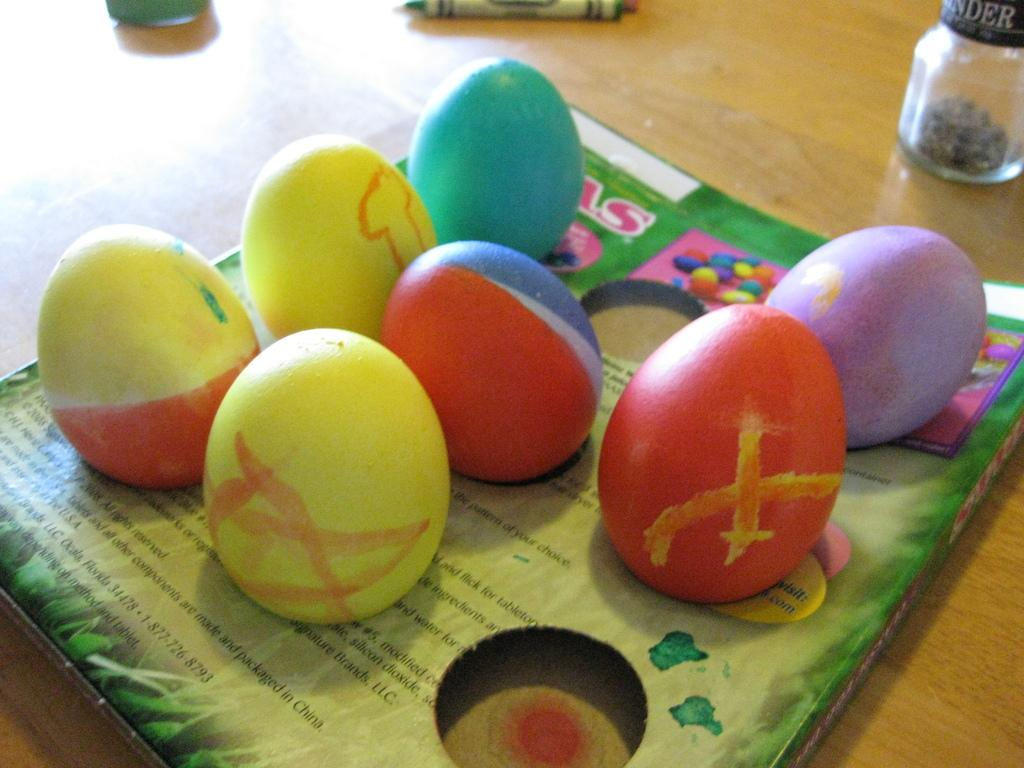How many easter eggs are visible in the image? There are six easter eggs on a cardboard box in the image. What else can be seen in the image besides the easter eggs? There is a jar in the image. Where are the easter eggs, jar, and crayon placed? The jar, easter eggs, and a crayon are placed on a wooden table. What shade of prose is used to describe the size of the easter eggs in the image? There is no prose or description of the easter eggs' size in the image. The image simply shows six easter eggs on a cardboard box. 